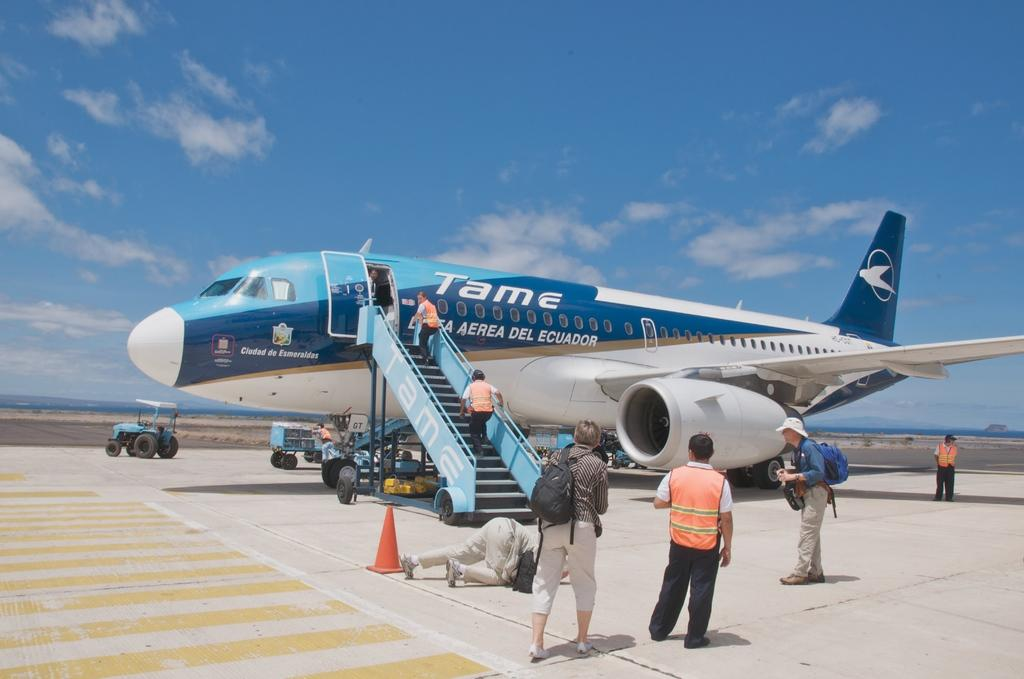<image>
Render a clear and concise summary of the photo. a plane that says tame on the side of it 